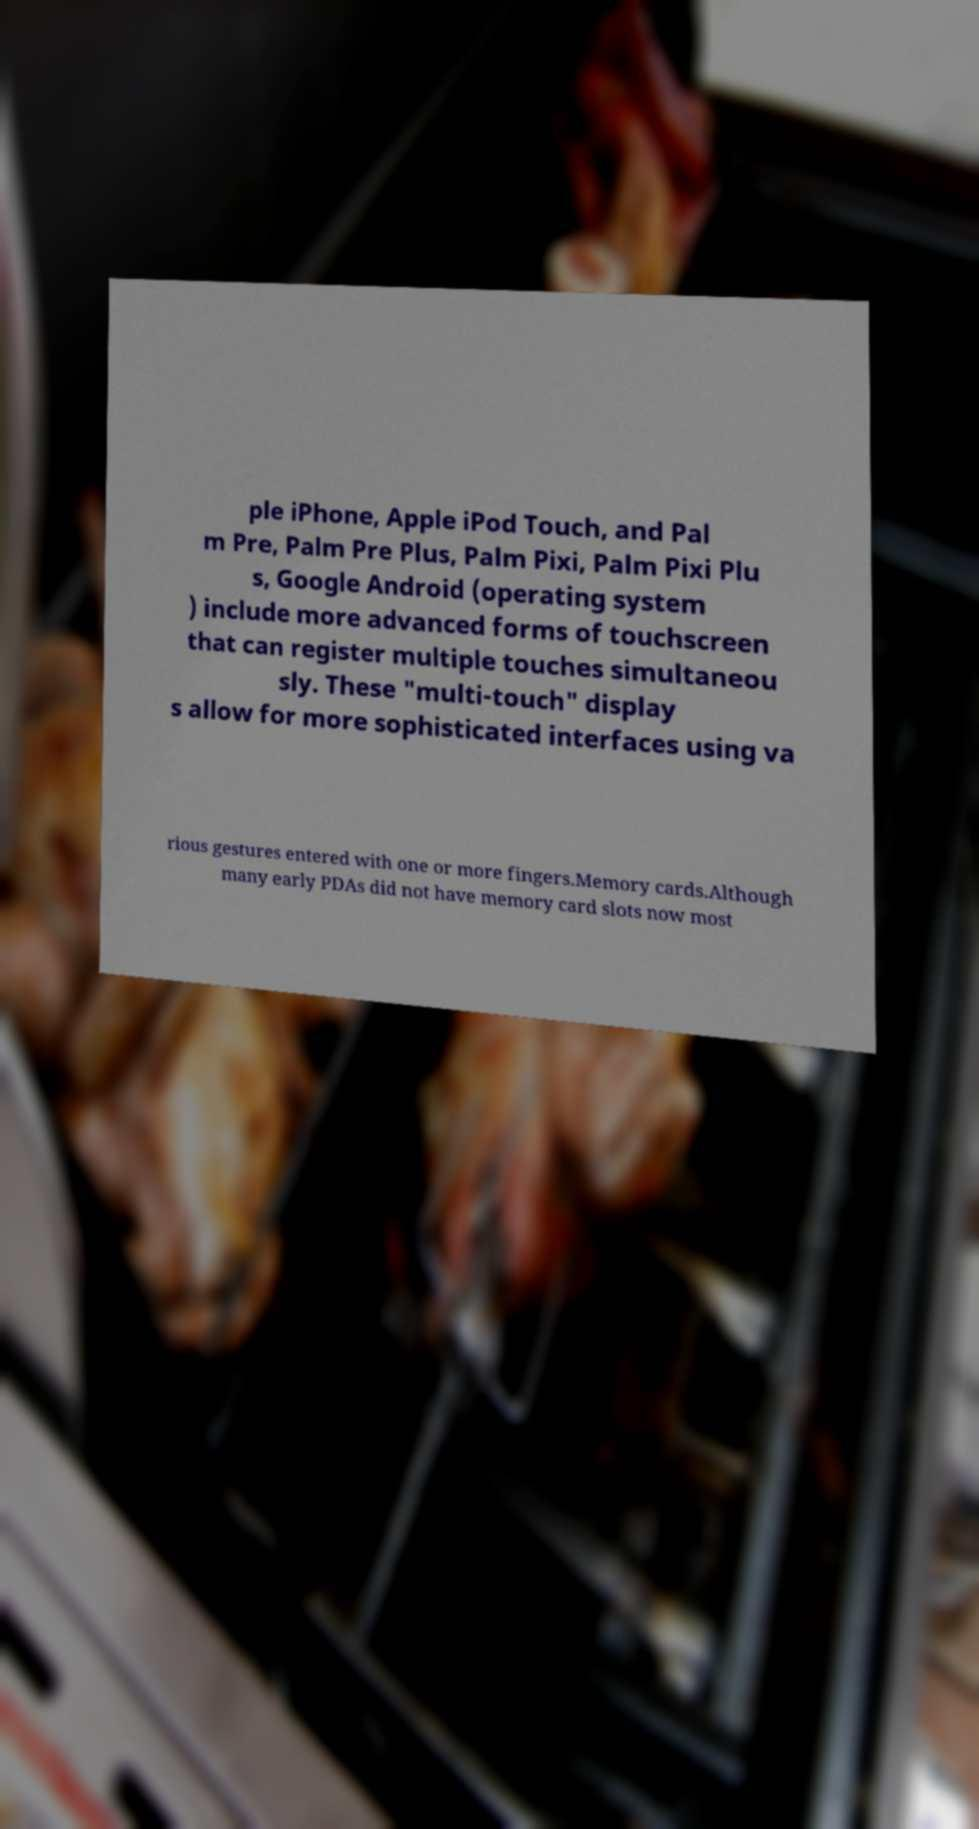Could you extract and type out the text from this image? ple iPhone, Apple iPod Touch, and Pal m Pre, Palm Pre Plus, Palm Pixi, Palm Pixi Plu s, Google Android (operating system ) include more advanced forms of touchscreen that can register multiple touches simultaneou sly. These "multi-touch" display s allow for more sophisticated interfaces using va rious gestures entered with one or more fingers.Memory cards.Although many early PDAs did not have memory card slots now most 